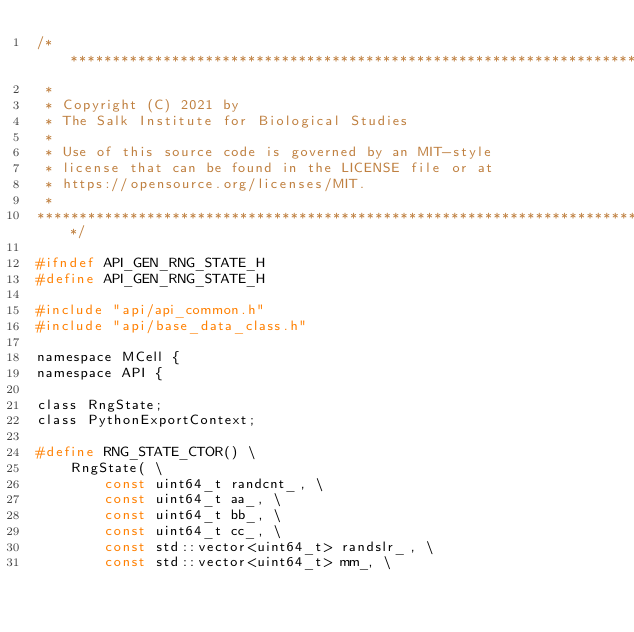<code> <loc_0><loc_0><loc_500><loc_500><_C_>/******************************************************************************
 *
 * Copyright (C) 2021 by
 * The Salk Institute for Biological Studies
 *
 * Use of this source code is governed by an MIT-style
 * license that can be found in the LICENSE file or at
 * https://opensource.org/licenses/MIT.
 *
******************************************************************************/

#ifndef API_GEN_RNG_STATE_H
#define API_GEN_RNG_STATE_H

#include "api/api_common.h"
#include "api/base_data_class.h"

namespace MCell {
namespace API {

class RngState;
class PythonExportContext;

#define RNG_STATE_CTOR() \
    RngState( \
        const uint64_t randcnt_, \
        const uint64_t aa_, \
        const uint64_t bb_, \
        const uint64_t cc_, \
        const std::vector<uint64_t> randslr_, \
        const std::vector<uint64_t> mm_, \</code> 